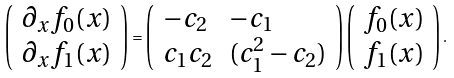<formula> <loc_0><loc_0><loc_500><loc_500>\left ( \begin{array} { c } \partial _ { x } f _ { 0 } ( x ) \\ \partial _ { x } f _ { 1 } ( x ) \end{array} \right ) = \left ( \begin{array} { l l } - c _ { 2 } & - c _ { 1 } \\ c _ { 1 } c _ { 2 } & ( c _ { 1 } ^ { 2 } - c _ { 2 } ) \end{array} \right ) \left ( \begin{array} { c } f _ { 0 } ( x ) \\ f _ { 1 } ( x ) \end{array} \right ) .</formula> 